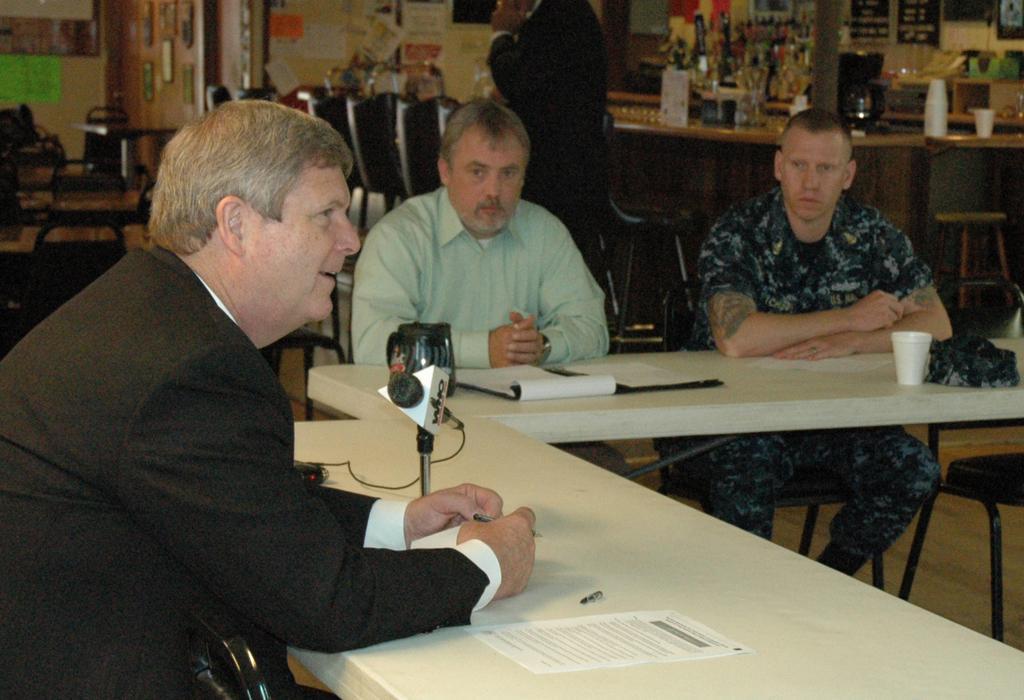Please provide a concise description of this image. In this image in front there are few persons sitting on the chair. In front of them there is a table and on top of the table there are papers, mike, cups. Behind them there is another table and there are few objects on the table. In front of the table there are chairs. On the backside there is a wall with the photo frames and posters on it. 